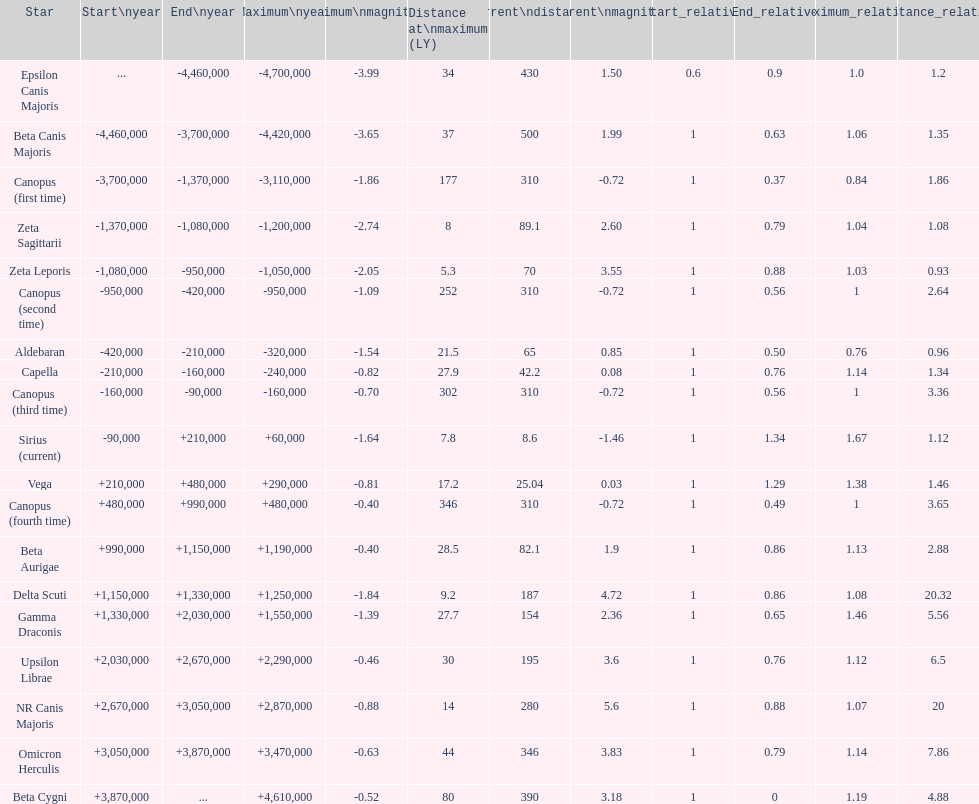How many stars do not have a current magnitude greater than zero? 5. I'm looking to parse the entire table for insights. Could you assist me with that? {'header': ['Star', 'Start\\nyear', 'End\\nyear', 'Maximum\\nyear', 'Maximum\\nmagnitude', 'Distance at\\nmaximum (LY)', 'Current\\ndistance', 'Current\\nmagnitude', 'Start_relative', 'End_relative', 'Maximum_relative', 'Distance_relative'], 'rows': [['Epsilon Canis Majoris', '...', '-4,460,000', '-4,700,000', '-3.99', '34', '430', '1.50', '0.6', '0.9', '1.0', '1.2'], ['Beta Canis Majoris', '-4,460,000', '-3,700,000', '-4,420,000', '-3.65', '37', '500', '1.99', '1', '0.63', '1.06', '1.35'], ['Canopus (first time)', '-3,700,000', '-1,370,000', '-3,110,000', '-1.86', '177', '310', '-0.72', '1', '0.37', '0.84', '1.86'], ['Zeta Sagittarii', '-1,370,000', '-1,080,000', '-1,200,000', '-2.74', '8', '89.1', '2.60', '1', '0.79', '1.04', '1.08'], ['Zeta Leporis', '-1,080,000', '-950,000', '-1,050,000', '-2.05', '5.3', '70', '3.55', '1', '0.88', '1.03', '0.93'], ['Canopus (second time)', '-950,000', '-420,000', '-950,000', '-1.09', '252', '310', '-0.72', '1', '0.56', '1', '2.64'], ['Aldebaran', '-420,000', '-210,000', '-320,000', '-1.54', '21.5', '65', '0.85', '1', '0.50', '0.76', '0.96'], ['Capella', '-210,000', '-160,000', '-240,000', '-0.82', '27.9', '42.2', '0.08', '1', '0.76', '1.14', '1.34'], ['Canopus (third time)', '-160,000', '-90,000', '-160,000', '-0.70', '302', '310', '-0.72', '1', '0.56', '1', '3.36'], ['Sirius (current)', '-90,000', '+210,000', '+60,000', '-1.64', '7.8', '8.6', '-1.46', '1', '1.34', '1.67', '1.12'], ['Vega', '+210,000', '+480,000', '+290,000', '-0.81', '17.2', '25.04', '0.03', '1', '1.29', '1.38', '1.46'], ['Canopus (fourth time)', '+480,000', '+990,000', '+480,000', '-0.40', '346', '310', '-0.72', '1', '0.49', '1', '3.65'], ['Beta Aurigae', '+990,000', '+1,150,000', '+1,190,000', '-0.40', '28.5', '82.1', '1.9', '1', '0.86', '1.13', '2.88'], ['Delta Scuti', '+1,150,000', '+1,330,000', '+1,250,000', '-1.84', '9.2', '187', '4.72', '1', '0.86', '1.08', '20.32'], ['Gamma Draconis', '+1,330,000', '+2,030,000', '+1,550,000', '-1.39', '27.7', '154', '2.36', '1', '0.65', '1.46', '5.56'], ['Upsilon Librae', '+2,030,000', '+2,670,000', '+2,290,000', '-0.46', '30', '195', '3.6', '1', '0.76', '1.12', '6.5'], ['NR Canis Majoris', '+2,670,000', '+3,050,000', '+2,870,000', '-0.88', '14', '280', '5.6', '1', '0.88', '1.07', '20'], ['Omicron Herculis', '+3,050,000', '+3,870,000', '+3,470,000', '-0.63', '44', '346', '3.83', '1', '0.79', '1.14', '7.86'], ['Beta Cygni', '+3,870,000', '...', '+4,610,000', '-0.52', '80', '390', '3.18', '1', '0', '1.19', '4.88']]} 